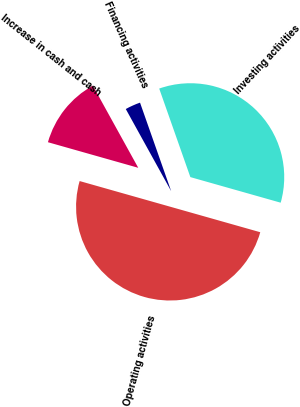Convert chart to OTSL. <chart><loc_0><loc_0><loc_500><loc_500><pie_chart><fcel>Operating activities<fcel>Investing activities<fcel>Financing activities<fcel>Increase in cash and cash<nl><fcel>50.0%<fcel>34.78%<fcel>2.65%<fcel>12.57%<nl></chart> 